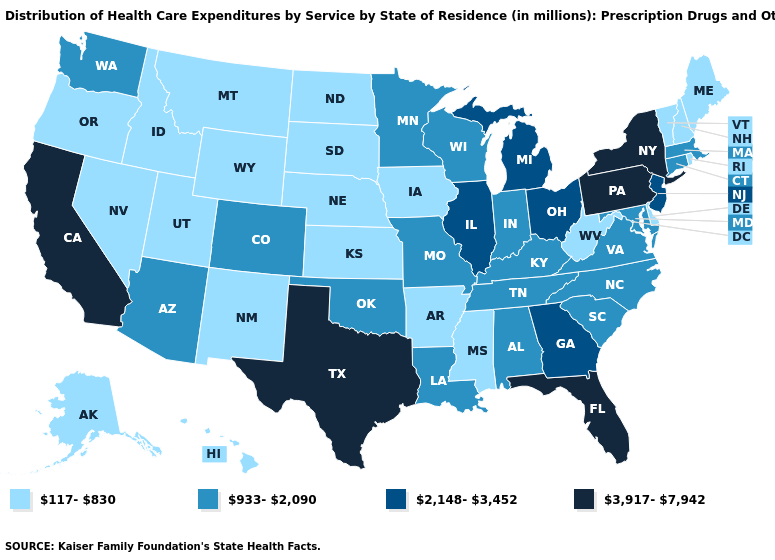What is the lowest value in the USA?
Answer briefly. 117-830. Which states have the lowest value in the USA?
Give a very brief answer. Alaska, Arkansas, Delaware, Hawaii, Idaho, Iowa, Kansas, Maine, Mississippi, Montana, Nebraska, Nevada, New Hampshire, New Mexico, North Dakota, Oregon, Rhode Island, South Dakota, Utah, Vermont, West Virginia, Wyoming. Does Maine have the lowest value in the Northeast?
Short answer required. Yes. What is the value of Kentucky?
Short answer required. 933-2,090. What is the value of Alaska?
Concise answer only. 117-830. Among the states that border New Hampshire , which have the highest value?
Quick response, please. Massachusetts. What is the value of New Jersey?
Keep it brief. 2,148-3,452. Which states have the highest value in the USA?
Be succinct. California, Florida, New York, Pennsylvania, Texas. Does North Dakota have the lowest value in the USA?
Quick response, please. Yes. Name the states that have a value in the range 2,148-3,452?
Be succinct. Georgia, Illinois, Michigan, New Jersey, Ohio. Does the first symbol in the legend represent the smallest category?
Short answer required. Yes. What is the value of Pennsylvania?
Answer briefly. 3,917-7,942. What is the value of Arizona?
Concise answer only. 933-2,090. Does Georgia have the lowest value in the USA?
Be succinct. No. What is the value of Alaska?
Write a very short answer. 117-830. 